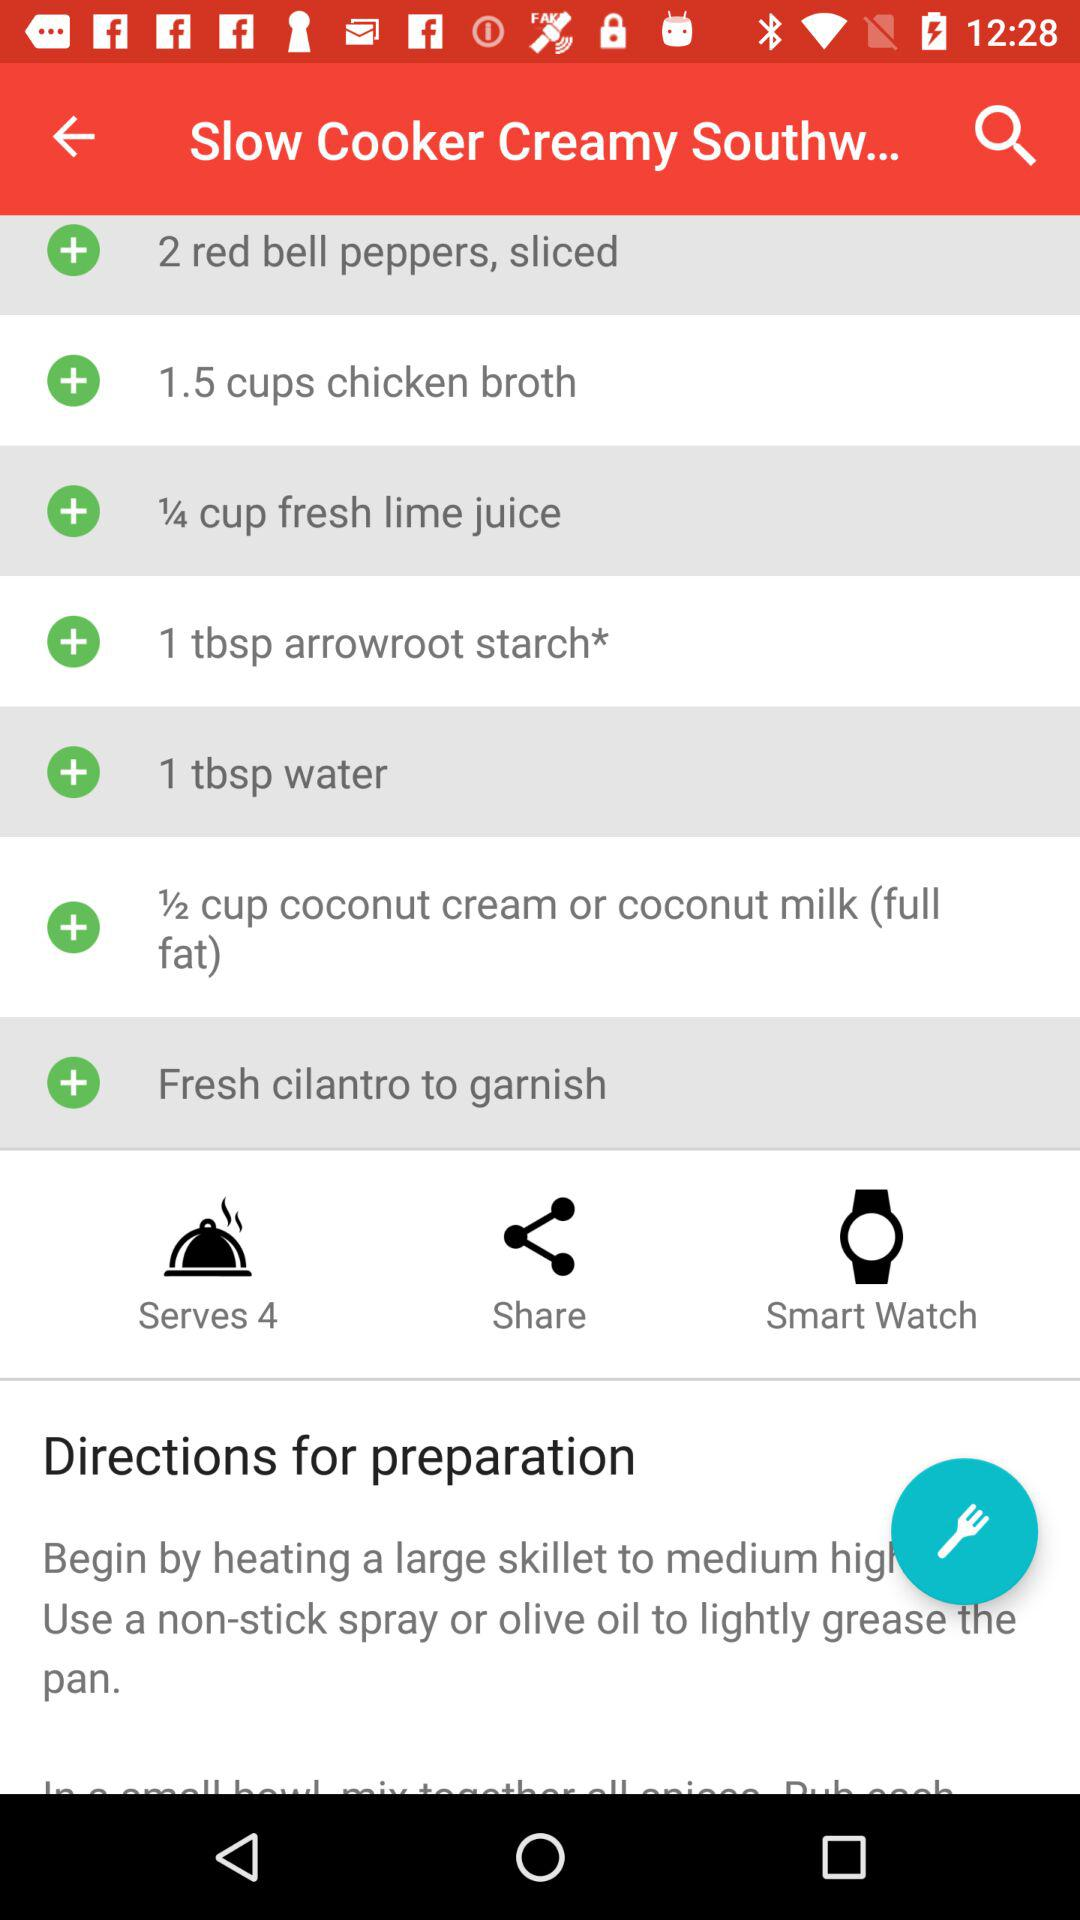What are the directions for preparation?
When the provided information is insufficient, respond with <no answer>. <no answer> 